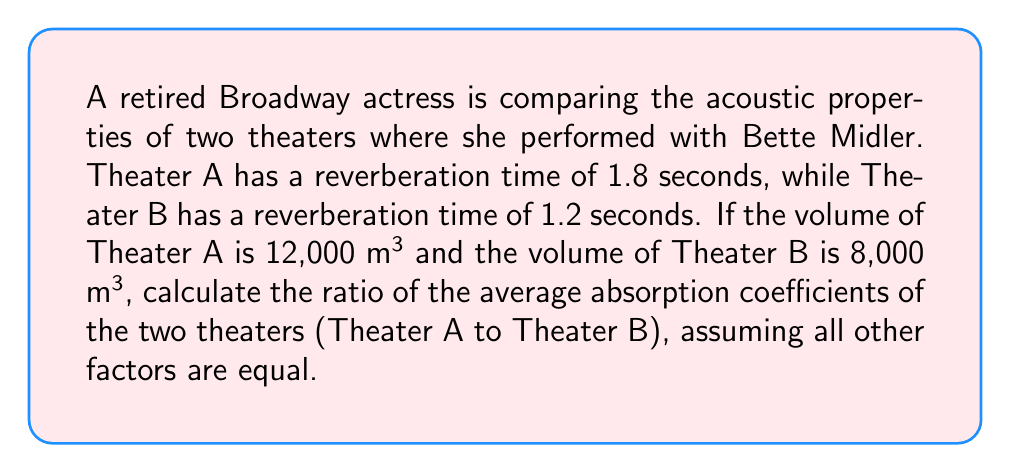Teach me how to tackle this problem. To solve this problem, we'll use the Sabine formula for reverberation time:

$$T = \frac{0.161V}{S\alpha}$$

Where:
$T$ = reverberation time (s)
$V$ = volume of the room (m³)
$S$ = total surface area of the room (m²)
$\alpha$ = average absorption coefficient

1. For Theater A:
   $$1.8 = \frac{0.161 \times 12000}{S_A\alpha_A}$$

2. For Theater B:
   $$1.2 = \frac{0.161 \times 8000}{S_B\alpha_B}$$

3. Assuming the surface area to volume ratio is similar for both theaters, we can say:
   $$\frac{S_A}{V_A} = \frac{S_B}{V_B}$$
   $$\frac{S_A}{12000} = \frac{S_B}{8000}$$
   $$S_A = \frac{3}{2}S_B$$

4. Substituting this into the equations from steps 1 and 2:
   $$1.8 = \frac{0.161 \times 12000}{\frac{3}{2}S_B\alpha_A}$$
   $$1.2 = \frac{0.161 \times 8000}{S_B\alpha_B}$$

5. Dividing the second equation by the first:
   $$\frac{1.2}{1.8} = \frac{\frac{0.161 \times 8000}{S_B\alpha_B}}{\frac{0.161 \times 12000}{\frac{3}{2}S_B\alpha_A}}$$

6. Simplifying:
   $$\frac{2}{3} = \frac{8000 \times \frac{3}{2}S_B\alpha_A}{12000 \times S_B\alpha_B} = \frac{\alpha_A}{\alpha_B}$$

7. Therefore, the ratio of the average absorption coefficients (Theater A to Theater B) is:
   $$\frac{\alpha_A}{\alpha_B} = \frac{2}{3}$$
Answer: $\frac{2}{3}$ 